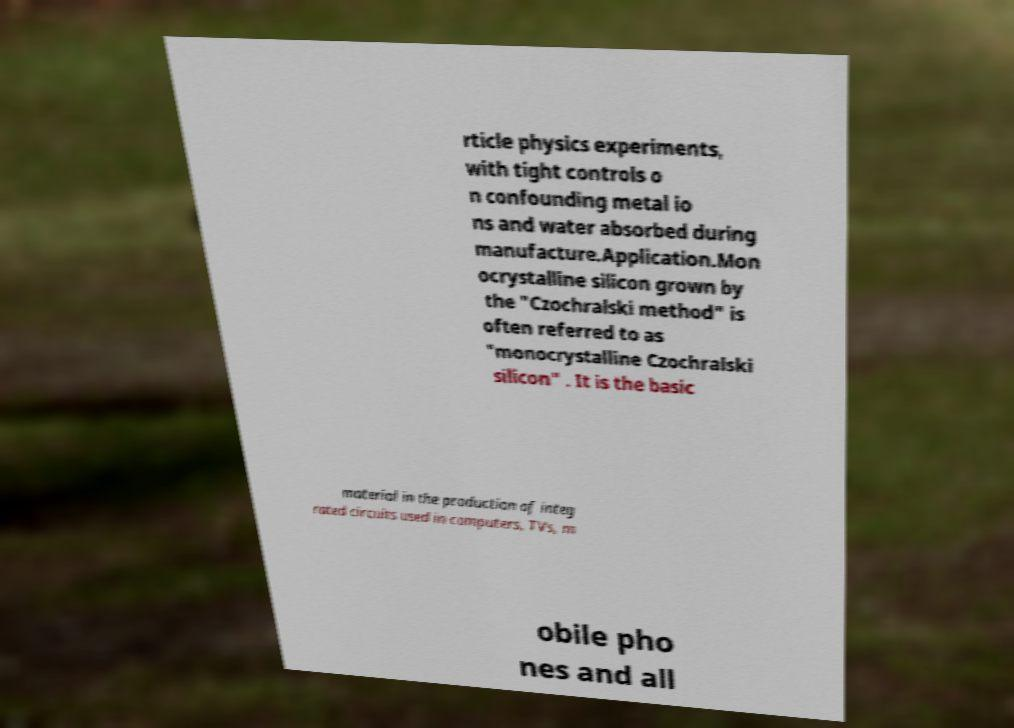I need the written content from this picture converted into text. Can you do that? rticle physics experiments, with tight controls o n confounding metal io ns and water absorbed during manufacture.Application.Mon ocrystalline silicon grown by the "Czochralski method" is often referred to as "monocrystalline Czochralski silicon" . It is the basic material in the production of integ rated circuits used in computers, TVs, m obile pho nes and all 